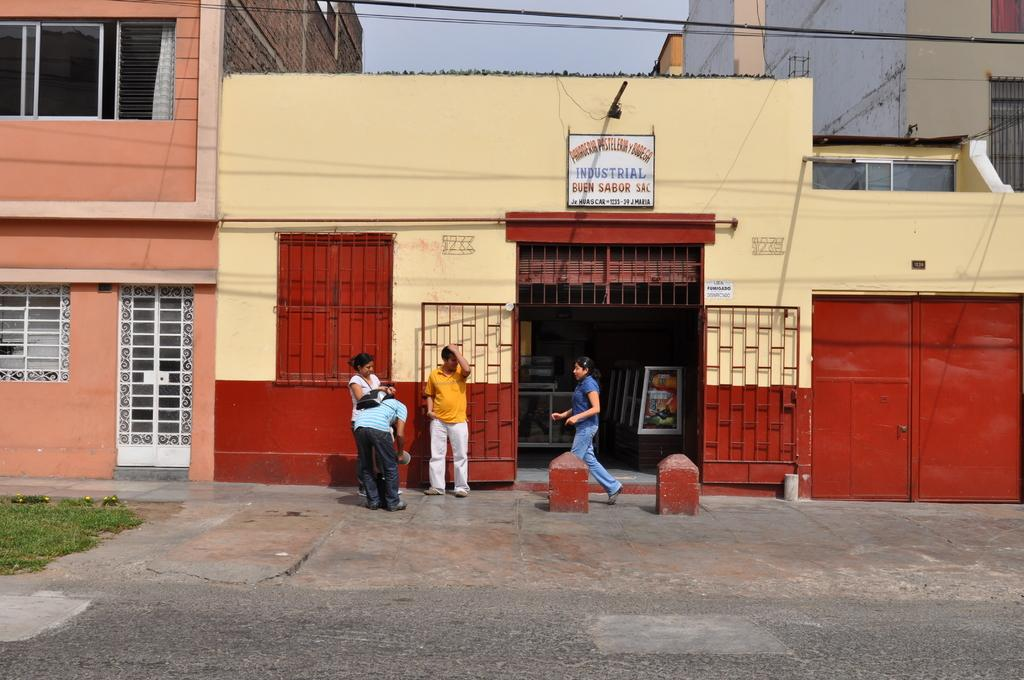How many people are present in the image? There are four persons in the image. What type of terrain is visible in the image? There is grass in the image. What architectural feature can be seen in the image? There is a gate in the image. What type of structure is present in the image? There are boards and buildings in the image. What part of the buildings can be seen in the image? There are windows in the image. What type of pathway is visible in the image? There is a road in the image. What is visible in the background of the image? The sky is visible in the background of the image. What type of sweater is the person wearing in the image? There is no sweater visible in the image; the people are not wearing any clothing. What place is depicted in the image? The image does not depict a specific place; it is a general scene with grass, a gate, buildings, and a road. 